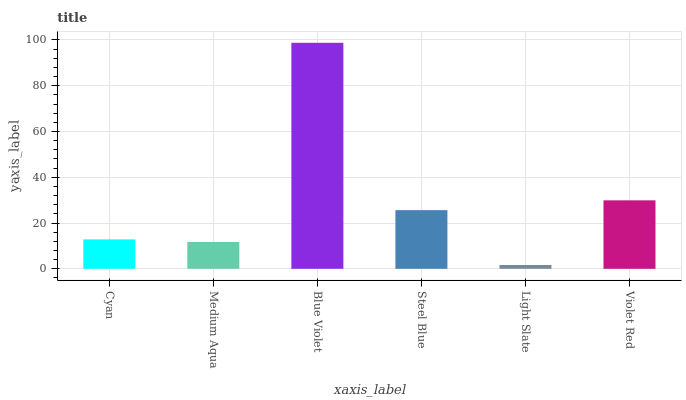Is Medium Aqua the minimum?
Answer yes or no. No. Is Medium Aqua the maximum?
Answer yes or no. No. Is Cyan greater than Medium Aqua?
Answer yes or no. Yes. Is Medium Aqua less than Cyan?
Answer yes or no. Yes. Is Medium Aqua greater than Cyan?
Answer yes or no. No. Is Cyan less than Medium Aqua?
Answer yes or no. No. Is Steel Blue the high median?
Answer yes or no. Yes. Is Cyan the low median?
Answer yes or no. Yes. Is Light Slate the high median?
Answer yes or no. No. Is Violet Red the low median?
Answer yes or no. No. 